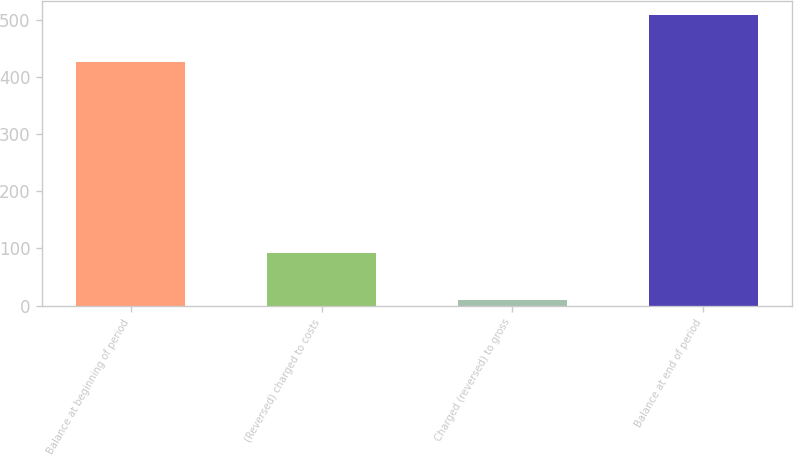Convert chart. <chart><loc_0><loc_0><loc_500><loc_500><bar_chart><fcel>Balance at beginning of period<fcel>(Reversed) charged to costs<fcel>Charged (reversed) to gross<fcel>Balance at end of period<nl><fcel>425.5<fcel>92.3<fcel>9.7<fcel>508.1<nl></chart> 